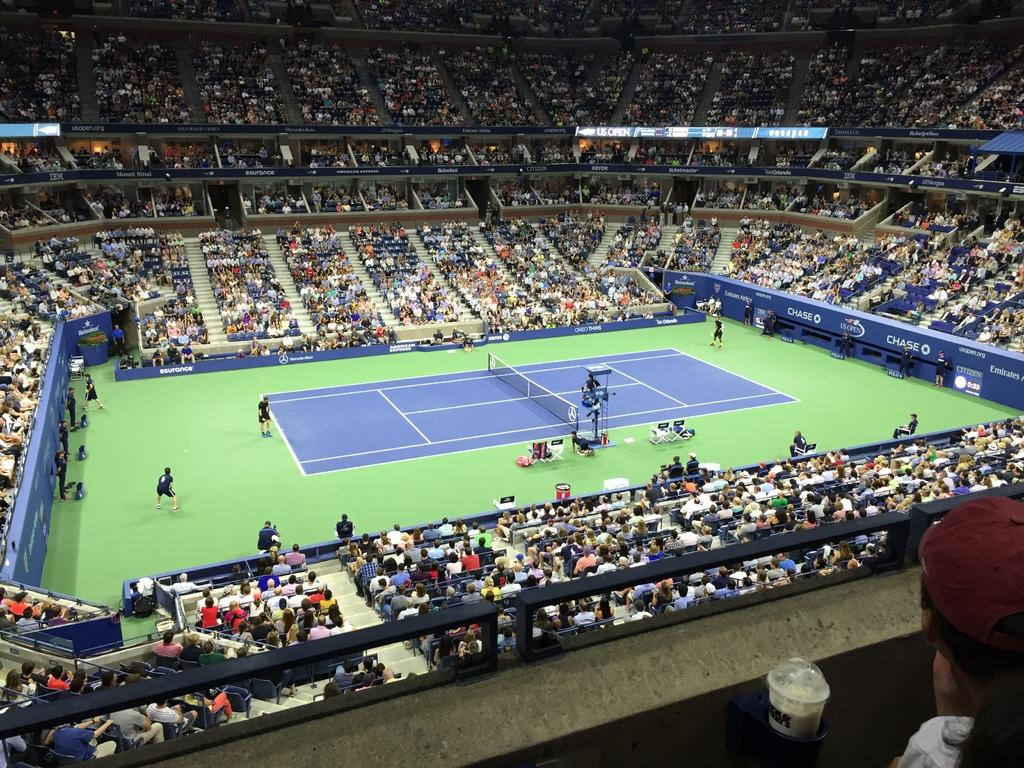What type of sports facility is shown in the image? There is a small tennis stadium in the image. What activity is taking place in the stadium? Players are playing in the stadium. Where are the players located within the stadium? The players are in the courtyard. How many people are watching the game in the stadium? There are many audience members in the stadium. What are the audience members doing during the game? The audience members are sitting and enjoying the game. What type of flower is being used as a ball in the game? There is no flower being used as a ball in the game; tennis balls are used in the image. Can you tell me about the history of the pig in the image? There is no pig present in the image, so it is not possible to discuss its history. 